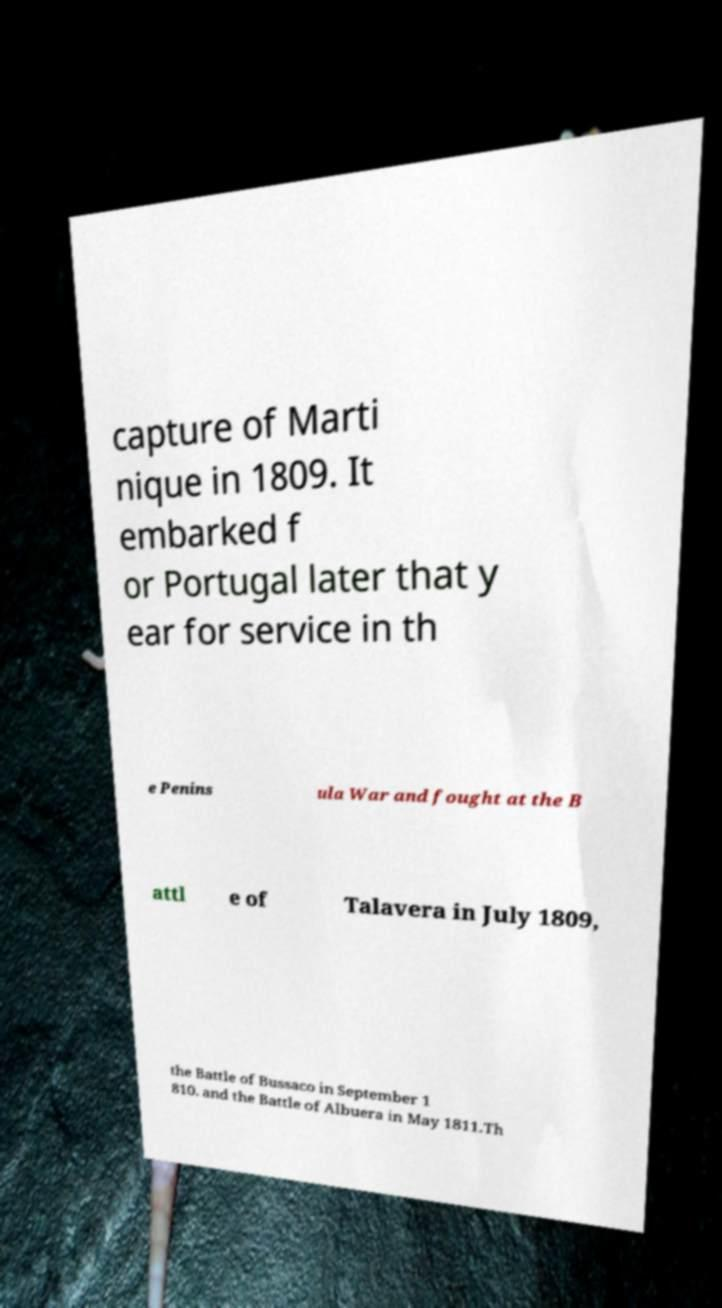Could you assist in decoding the text presented in this image and type it out clearly? capture of Marti nique in 1809. It embarked f or Portugal later that y ear for service in th e Penins ula War and fought at the B attl e of Talavera in July 1809, the Battle of Bussaco in September 1 810. and the Battle of Albuera in May 1811.Th 